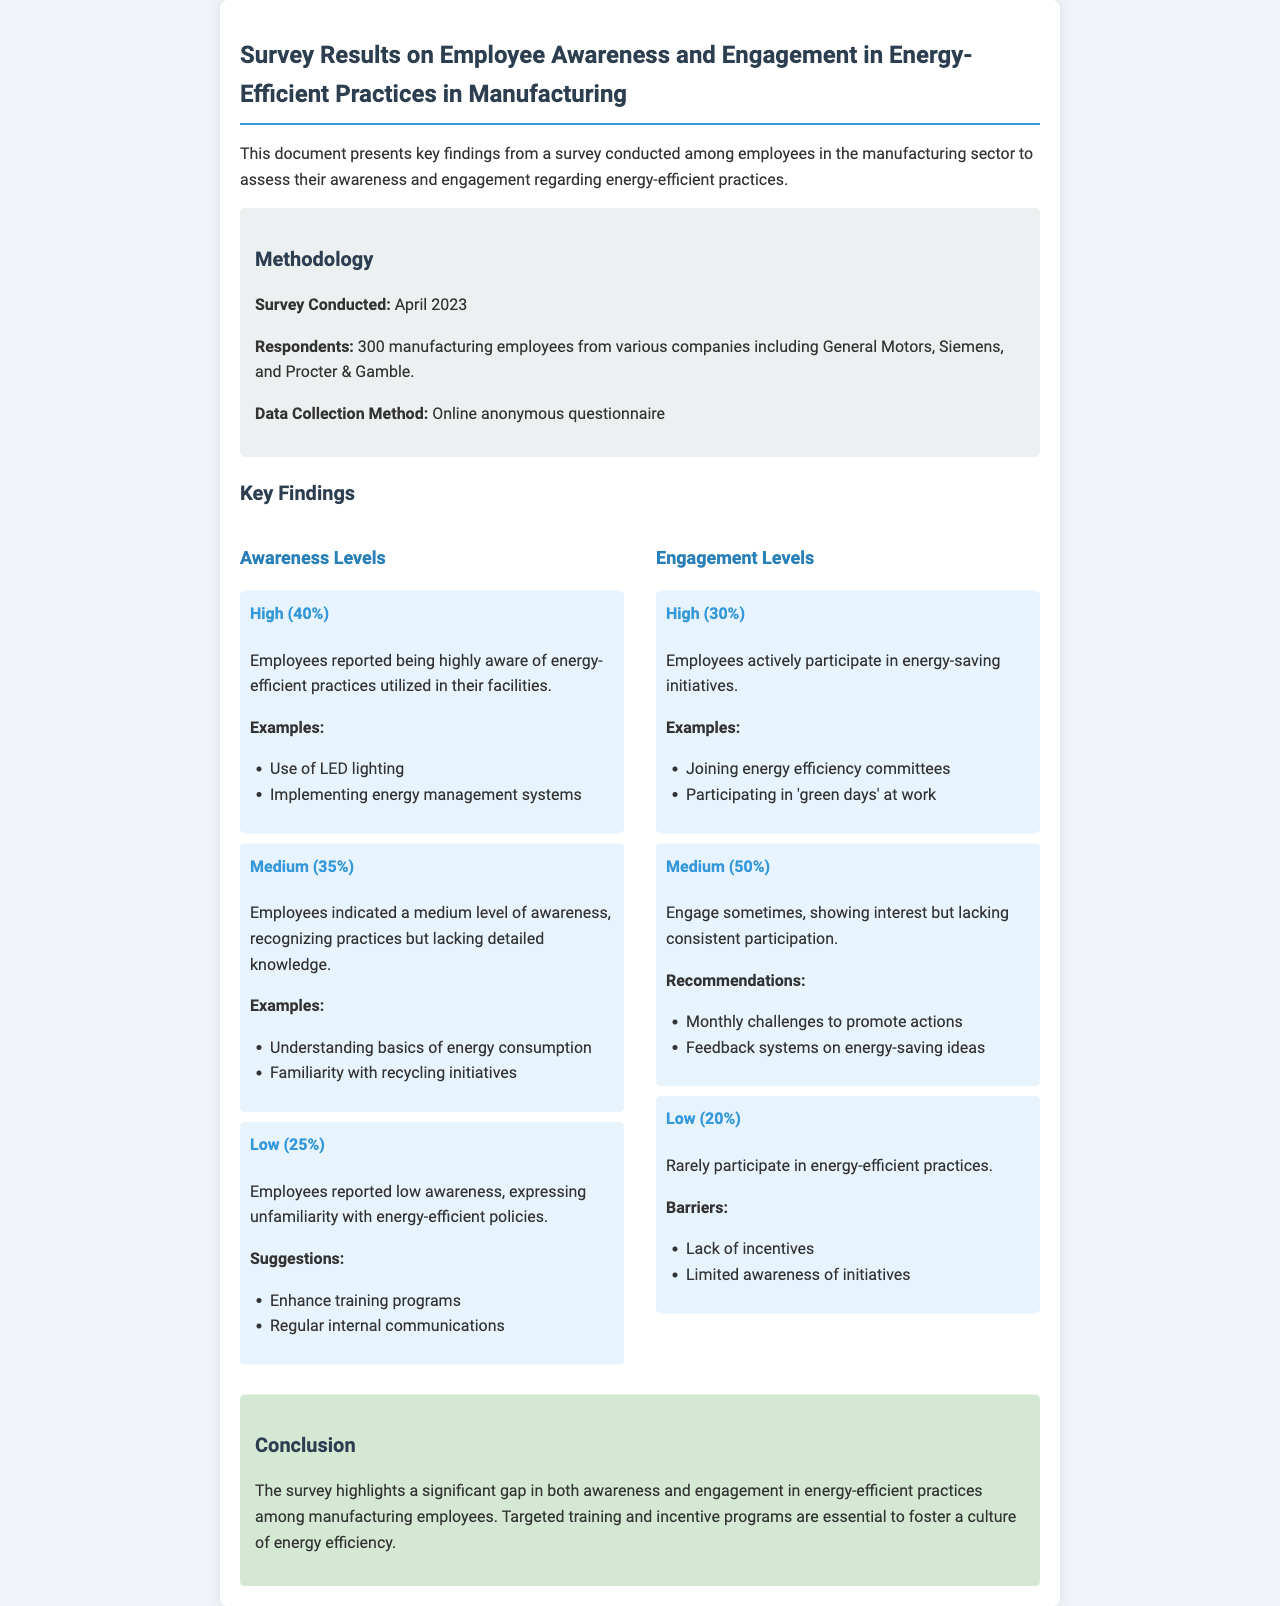What is the percentage of employees with high awareness? The document states that 40% of employees reported being highly aware of energy-efficient practices.
Answer: 40% What were the companies involved in the survey? The survey respondents came from companies including General Motors, Siemens, and Procter & Gamble.
Answer: General Motors, Siemens, Procter & Gamble What is the method of data collection used in the survey? The document mentions that the data was collected through an online anonymous questionnaire.
Answer: Online anonymous questionnaire How many employees participated in the survey? The total number of respondents mentioned in the document is 300 manufacturing employees.
Answer: 300 What percentage of employees show high engagement levels? According to the document, 30% of employees actively participate in energy-saving initiatives, which indicates high engagement levels.
Answer: 30% What was suggested to improve low awareness among employees? The document suggests enhancing training programs and regular internal communications to improve low awareness.
Answer: Enhance training programs What barriers prevent low engagement in energy-efficient practices? The document identifies lack of incentives and limited awareness of initiatives as barriers to low engagement.
Answer: Lack of incentives, limited awareness What was the conclusion regarding energy efficiency culture? The conclusion states that targeted training and incentive programs are essential to foster a culture of energy efficiency.
Answer: Targeted training and incentive programs What percentage of employees reported low awareness levels? The document indicates that 25% of employees reported low awareness regarding energy-efficient practices.
Answer: 25% 